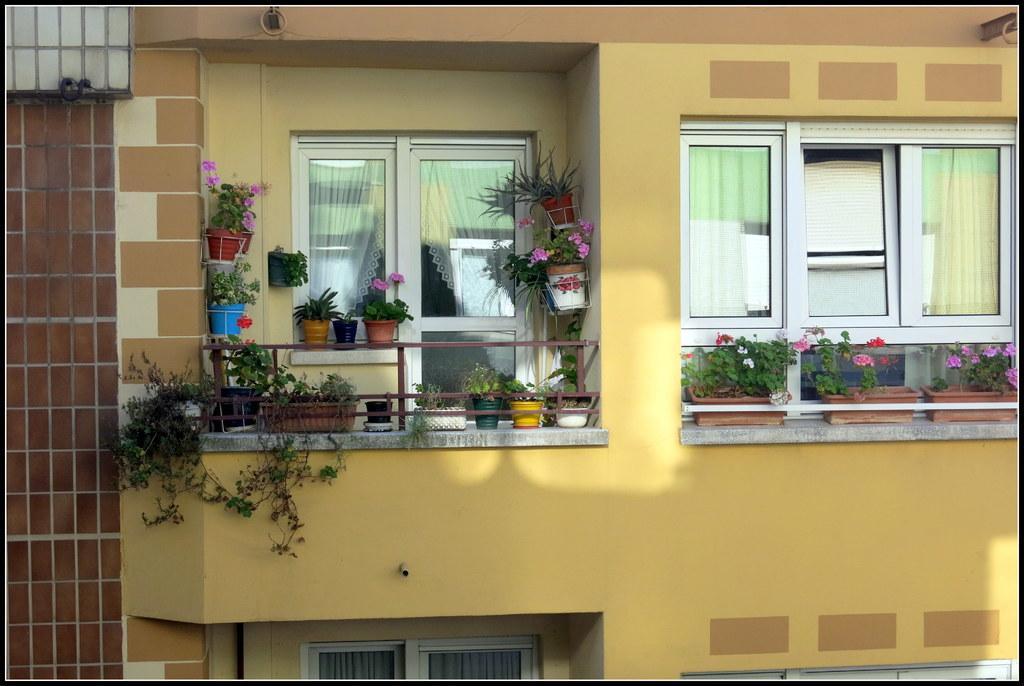Can you describe this image briefly? In this image I can see in the middle there are flower plants and there are glass windows. It looks like an outside part of a building. 